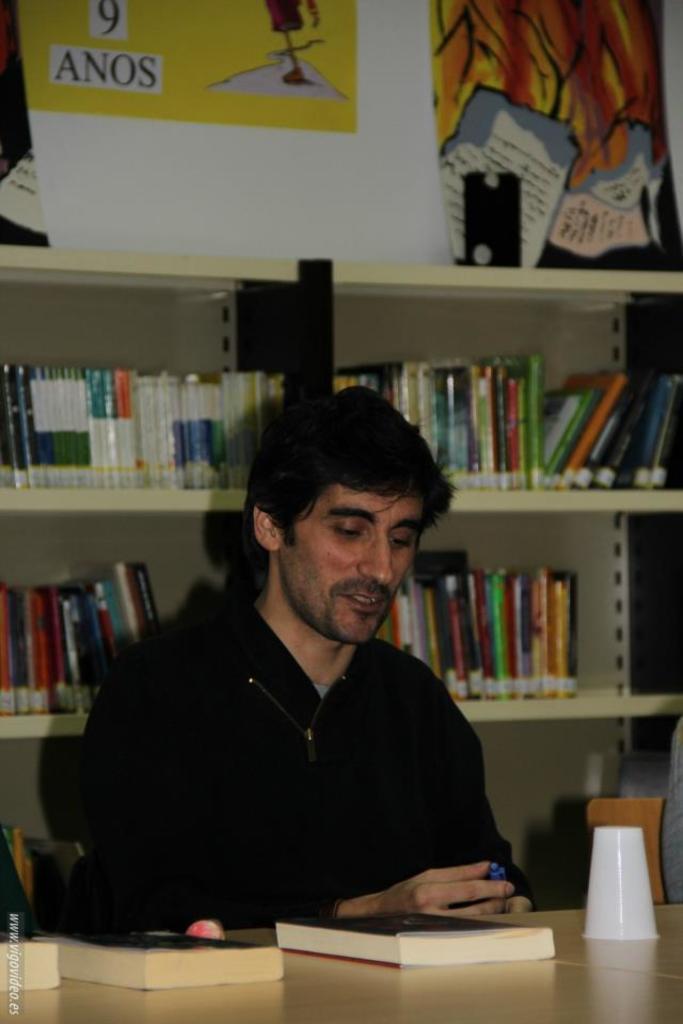How would you summarize this image in a sentence or two? A man is sitting in a library with a book in front of him. 